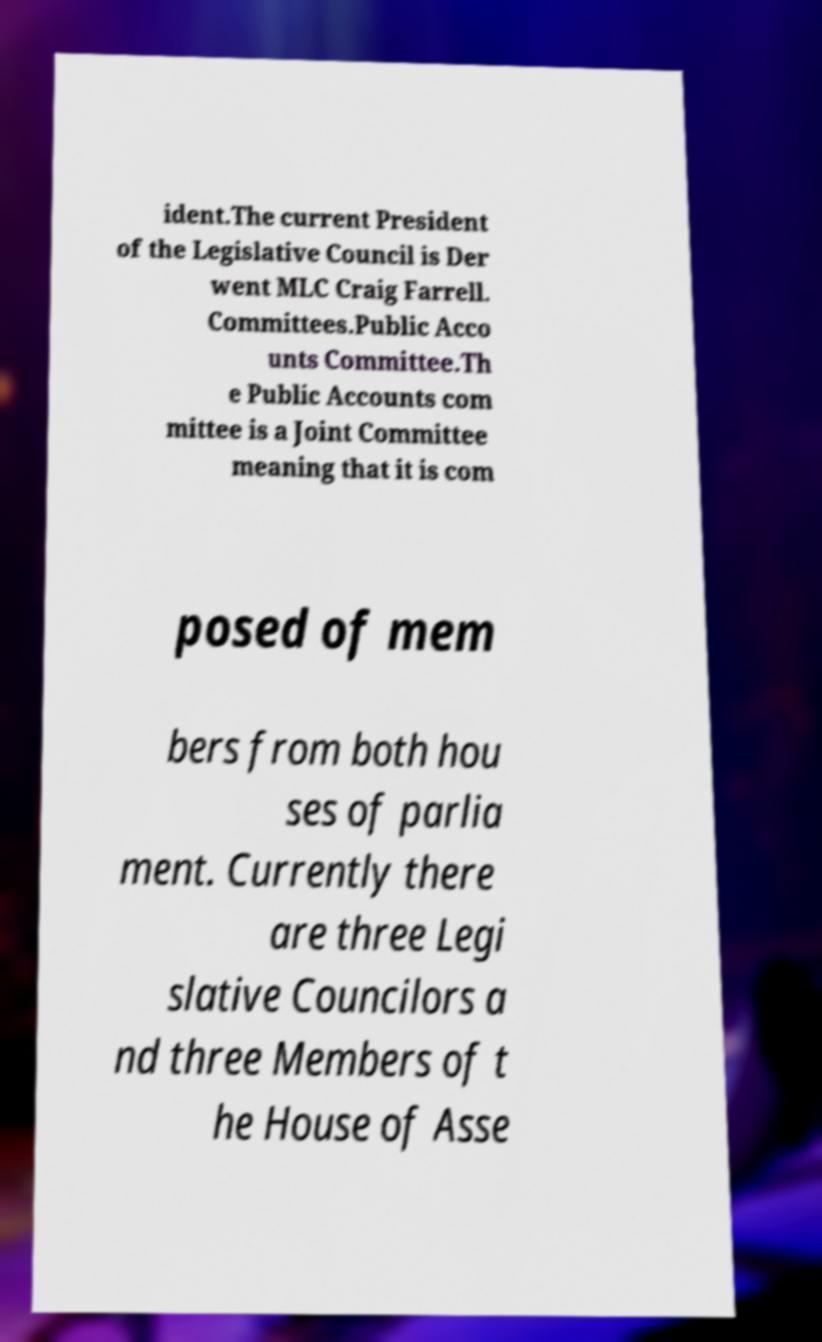What messages or text are displayed in this image? I need them in a readable, typed format. ident.The current President of the Legislative Council is Der went MLC Craig Farrell. Committees.Public Acco unts Committee.Th e Public Accounts com mittee is a Joint Committee meaning that it is com posed of mem bers from both hou ses of parlia ment. Currently there are three Legi slative Councilors a nd three Members of t he House of Asse 